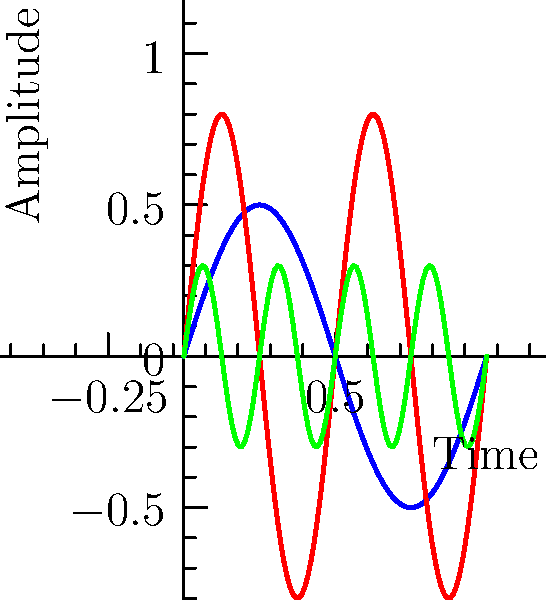In the graph above, three sound waves from different musical instruments are represented. Which wave likely corresponds to an instrument with the highest pitch? To determine which wave corresponds to the instrument with the highest pitch, we need to analyze the frequency of each wave. The frequency is inversely related to the wavelength and directly related to pitch. Here's a step-by-step analysis:

1. Wave A (blue): Has the longest wavelength, completing about 1 full cycle in the given time frame.
2. Wave B (red): Shows about 2 complete cycles in the same time frame.
3. Wave C (green): Displays approximately 4 complete cycles.

The more cycles completed in the same time frame, the higher the frequency. Higher frequency corresponds to higher pitch in music.

Therefore, Wave C, with the most cycles (highest frequency), represents the instrument with the highest pitch.

This analysis reminds us of how different instruments produce distinct sound waves, much like how various vinyl records used to showcase unique grooves representing different musical styles and pitches.
Answer: C (green wave) 